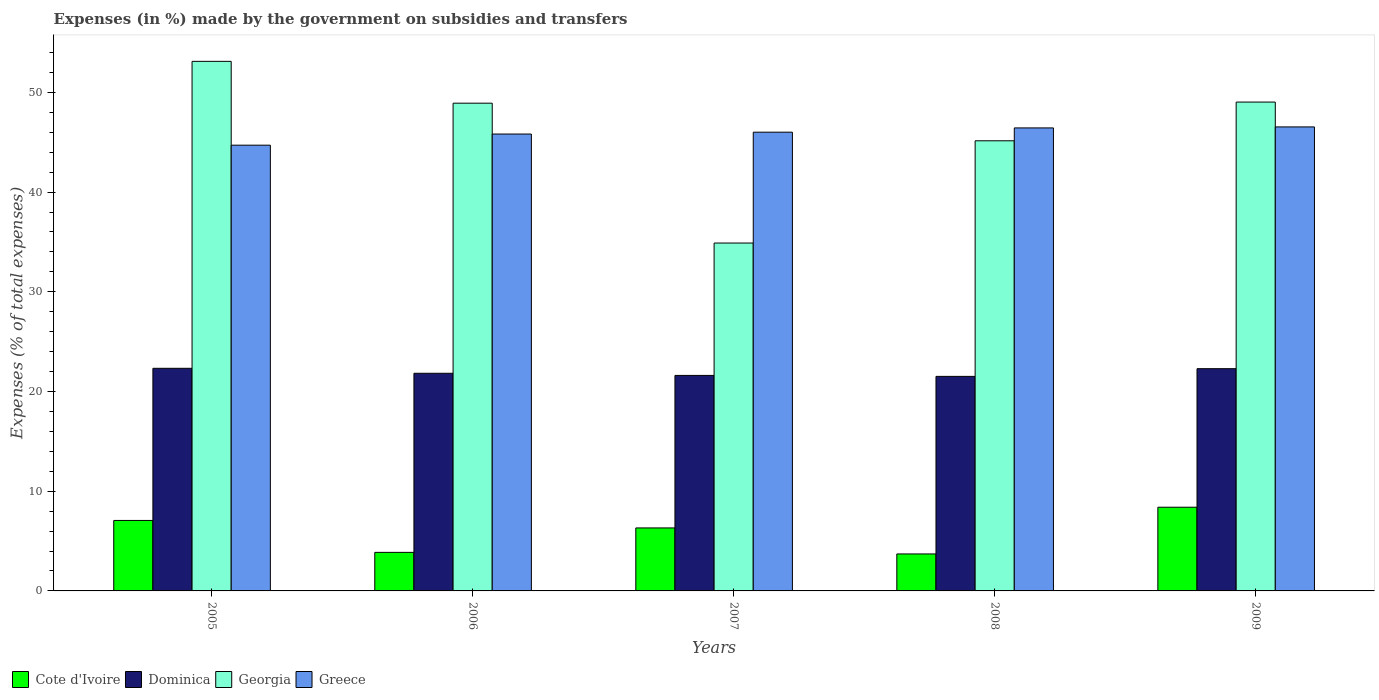How many different coloured bars are there?
Your answer should be very brief. 4. Are the number of bars on each tick of the X-axis equal?
Give a very brief answer. Yes. How many bars are there on the 4th tick from the left?
Your answer should be compact. 4. What is the label of the 1st group of bars from the left?
Offer a very short reply. 2005. In how many cases, is the number of bars for a given year not equal to the number of legend labels?
Your response must be concise. 0. What is the percentage of expenses made by the government on subsidies and transfers in Greece in 2009?
Your response must be concise. 46.53. Across all years, what is the maximum percentage of expenses made by the government on subsidies and transfers in Cote d'Ivoire?
Your answer should be very brief. 8.39. Across all years, what is the minimum percentage of expenses made by the government on subsidies and transfers in Cote d'Ivoire?
Give a very brief answer. 3.71. What is the total percentage of expenses made by the government on subsidies and transfers in Greece in the graph?
Keep it short and to the point. 229.49. What is the difference between the percentage of expenses made by the government on subsidies and transfers in Cote d'Ivoire in 2008 and that in 2009?
Your answer should be very brief. -4.69. What is the difference between the percentage of expenses made by the government on subsidies and transfers in Cote d'Ivoire in 2009 and the percentage of expenses made by the government on subsidies and transfers in Dominica in 2006?
Your response must be concise. -13.43. What is the average percentage of expenses made by the government on subsidies and transfers in Greece per year?
Make the answer very short. 45.9. In the year 2009, what is the difference between the percentage of expenses made by the government on subsidies and transfers in Georgia and percentage of expenses made by the government on subsidies and transfers in Dominica?
Offer a terse response. 26.74. In how many years, is the percentage of expenses made by the government on subsidies and transfers in Greece greater than 42 %?
Your answer should be very brief. 5. What is the ratio of the percentage of expenses made by the government on subsidies and transfers in Dominica in 2005 to that in 2006?
Provide a short and direct response. 1.02. Is the difference between the percentage of expenses made by the government on subsidies and transfers in Georgia in 2005 and 2007 greater than the difference between the percentage of expenses made by the government on subsidies and transfers in Dominica in 2005 and 2007?
Your answer should be very brief. Yes. What is the difference between the highest and the second highest percentage of expenses made by the government on subsidies and transfers in Dominica?
Provide a succinct answer. 0.04. What is the difference between the highest and the lowest percentage of expenses made by the government on subsidies and transfers in Dominica?
Your response must be concise. 0.81. In how many years, is the percentage of expenses made by the government on subsidies and transfers in Dominica greater than the average percentage of expenses made by the government on subsidies and transfers in Dominica taken over all years?
Ensure brevity in your answer.  2. What does the 1st bar from the left in 2006 represents?
Provide a succinct answer. Cote d'Ivoire. What does the 2nd bar from the right in 2006 represents?
Provide a succinct answer. Georgia. Is it the case that in every year, the sum of the percentage of expenses made by the government on subsidies and transfers in Cote d'Ivoire and percentage of expenses made by the government on subsidies and transfers in Georgia is greater than the percentage of expenses made by the government on subsidies and transfers in Greece?
Your answer should be compact. No. What is the difference between two consecutive major ticks on the Y-axis?
Your answer should be compact. 10. Are the values on the major ticks of Y-axis written in scientific E-notation?
Ensure brevity in your answer.  No. Does the graph contain any zero values?
Your answer should be compact. No. Does the graph contain grids?
Your answer should be compact. No. How many legend labels are there?
Keep it short and to the point. 4. What is the title of the graph?
Provide a succinct answer. Expenses (in %) made by the government on subsidies and transfers. Does "North America" appear as one of the legend labels in the graph?
Your answer should be compact. No. What is the label or title of the X-axis?
Keep it short and to the point. Years. What is the label or title of the Y-axis?
Make the answer very short. Expenses (% of total expenses). What is the Expenses (% of total expenses) in Cote d'Ivoire in 2005?
Give a very brief answer. 7.07. What is the Expenses (% of total expenses) of Dominica in 2005?
Keep it short and to the point. 22.33. What is the Expenses (% of total expenses) in Georgia in 2005?
Offer a terse response. 53.11. What is the Expenses (% of total expenses) in Greece in 2005?
Keep it short and to the point. 44.7. What is the Expenses (% of total expenses) of Cote d'Ivoire in 2006?
Make the answer very short. 3.87. What is the Expenses (% of total expenses) in Dominica in 2006?
Offer a very short reply. 21.83. What is the Expenses (% of total expenses) in Georgia in 2006?
Ensure brevity in your answer.  48.91. What is the Expenses (% of total expenses) of Greece in 2006?
Give a very brief answer. 45.82. What is the Expenses (% of total expenses) in Cote d'Ivoire in 2007?
Provide a short and direct response. 6.32. What is the Expenses (% of total expenses) in Dominica in 2007?
Offer a very short reply. 21.61. What is the Expenses (% of total expenses) in Georgia in 2007?
Your answer should be very brief. 34.89. What is the Expenses (% of total expenses) in Greece in 2007?
Keep it short and to the point. 46. What is the Expenses (% of total expenses) in Cote d'Ivoire in 2008?
Provide a succinct answer. 3.71. What is the Expenses (% of total expenses) in Dominica in 2008?
Provide a short and direct response. 21.52. What is the Expenses (% of total expenses) in Georgia in 2008?
Give a very brief answer. 45.14. What is the Expenses (% of total expenses) in Greece in 2008?
Your answer should be very brief. 46.43. What is the Expenses (% of total expenses) in Cote d'Ivoire in 2009?
Offer a very short reply. 8.39. What is the Expenses (% of total expenses) in Dominica in 2009?
Make the answer very short. 22.29. What is the Expenses (% of total expenses) in Georgia in 2009?
Give a very brief answer. 49.03. What is the Expenses (% of total expenses) in Greece in 2009?
Provide a short and direct response. 46.53. Across all years, what is the maximum Expenses (% of total expenses) of Cote d'Ivoire?
Give a very brief answer. 8.39. Across all years, what is the maximum Expenses (% of total expenses) of Dominica?
Your response must be concise. 22.33. Across all years, what is the maximum Expenses (% of total expenses) of Georgia?
Your response must be concise. 53.11. Across all years, what is the maximum Expenses (% of total expenses) of Greece?
Your answer should be compact. 46.53. Across all years, what is the minimum Expenses (% of total expenses) in Cote d'Ivoire?
Give a very brief answer. 3.71. Across all years, what is the minimum Expenses (% of total expenses) in Dominica?
Your answer should be compact. 21.52. Across all years, what is the minimum Expenses (% of total expenses) of Georgia?
Offer a very short reply. 34.89. Across all years, what is the minimum Expenses (% of total expenses) of Greece?
Offer a terse response. 44.7. What is the total Expenses (% of total expenses) of Cote d'Ivoire in the graph?
Give a very brief answer. 29.35. What is the total Expenses (% of total expenses) of Dominica in the graph?
Offer a very short reply. 109.57. What is the total Expenses (% of total expenses) in Georgia in the graph?
Give a very brief answer. 231.07. What is the total Expenses (% of total expenses) of Greece in the graph?
Your answer should be very brief. 229.49. What is the difference between the Expenses (% of total expenses) in Cote d'Ivoire in 2005 and that in 2006?
Keep it short and to the point. 3.2. What is the difference between the Expenses (% of total expenses) of Dominica in 2005 and that in 2006?
Your answer should be compact. 0.5. What is the difference between the Expenses (% of total expenses) in Georgia in 2005 and that in 2006?
Your answer should be very brief. 4.2. What is the difference between the Expenses (% of total expenses) in Greece in 2005 and that in 2006?
Provide a short and direct response. -1.12. What is the difference between the Expenses (% of total expenses) in Cote d'Ivoire in 2005 and that in 2007?
Your answer should be very brief. 0.75. What is the difference between the Expenses (% of total expenses) in Dominica in 2005 and that in 2007?
Your answer should be very brief. 0.71. What is the difference between the Expenses (% of total expenses) of Georgia in 2005 and that in 2007?
Provide a succinct answer. 18.22. What is the difference between the Expenses (% of total expenses) of Greece in 2005 and that in 2007?
Provide a succinct answer. -1.3. What is the difference between the Expenses (% of total expenses) in Cote d'Ivoire in 2005 and that in 2008?
Give a very brief answer. 3.36. What is the difference between the Expenses (% of total expenses) of Dominica in 2005 and that in 2008?
Your answer should be compact. 0.81. What is the difference between the Expenses (% of total expenses) in Georgia in 2005 and that in 2008?
Your answer should be very brief. 7.97. What is the difference between the Expenses (% of total expenses) of Greece in 2005 and that in 2008?
Offer a very short reply. -1.73. What is the difference between the Expenses (% of total expenses) of Cote d'Ivoire in 2005 and that in 2009?
Offer a terse response. -1.33. What is the difference between the Expenses (% of total expenses) of Dominica in 2005 and that in 2009?
Provide a succinct answer. 0.04. What is the difference between the Expenses (% of total expenses) of Georgia in 2005 and that in 2009?
Provide a succinct answer. 4.08. What is the difference between the Expenses (% of total expenses) in Greece in 2005 and that in 2009?
Offer a very short reply. -1.83. What is the difference between the Expenses (% of total expenses) in Cote d'Ivoire in 2006 and that in 2007?
Offer a very short reply. -2.45. What is the difference between the Expenses (% of total expenses) in Dominica in 2006 and that in 2007?
Offer a very short reply. 0.21. What is the difference between the Expenses (% of total expenses) in Georgia in 2006 and that in 2007?
Ensure brevity in your answer.  14.03. What is the difference between the Expenses (% of total expenses) of Greece in 2006 and that in 2007?
Offer a terse response. -0.19. What is the difference between the Expenses (% of total expenses) of Cote d'Ivoire in 2006 and that in 2008?
Provide a succinct answer. 0.16. What is the difference between the Expenses (% of total expenses) in Dominica in 2006 and that in 2008?
Give a very brief answer. 0.31. What is the difference between the Expenses (% of total expenses) in Georgia in 2006 and that in 2008?
Offer a very short reply. 3.77. What is the difference between the Expenses (% of total expenses) in Greece in 2006 and that in 2008?
Your answer should be compact. -0.61. What is the difference between the Expenses (% of total expenses) in Cote d'Ivoire in 2006 and that in 2009?
Offer a very short reply. -4.53. What is the difference between the Expenses (% of total expenses) in Dominica in 2006 and that in 2009?
Keep it short and to the point. -0.46. What is the difference between the Expenses (% of total expenses) in Georgia in 2006 and that in 2009?
Keep it short and to the point. -0.11. What is the difference between the Expenses (% of total expenses) of Greece in 2006 and that in 2009?
Offer a terse response. -0.71. What is the difference between the Expenses (% of total expenses) in Cote d'Ivoire in 2007 and that in 2008?
Offer a very short reply. 2.61. What is the difference between the Expenses (% of total expenses) of Dominica in 2007 and that in 2008?
Provide a short and direct response. 0.1. What is the difference between the Expenses (% of total expenses) in Georgia in 2007 and that in 2008?
Your response must be concise. -10.26. What is the difference between the Expenses (% of total expenses) of Greece in 2007 and that in 2008?
Keep it short and to the point. -0.43. What is the difference between the Expenses (% of total expenses) in Cote d'Ivoire in 2007 and that in 2009?
Provide a short and direct response. -2.08. What is the difference between the Expenses (% of total expenses) of Dominica in 2007 and that in 2009?
Give a very brief answer. -0.68. What is the difference between the Expenses (% of total expenses) of Georgia in 2007 and that in 2009?
Your response must be concise. -14.14. What is the difference between the Expenses (% of total expenses) of Greece in 2007 and that in 2009?
Your answer should be very brief. -0.53. What is the difference between the Expenses (% of total expenses) in Cote d'Ivoire in 2008 and that in 2009?
Your answer should be very brief. -4.69. What is the difference between the Expenses (% of total expenses) in Dominica in 2008 and that in 2009?
Keep it short and to the point. -0.77. What is the difference between the Expenses (% of total expenses) of Georgia in 2008 and that in 2009?
Your answer should be very brief. -3.88. What is the difference between the Expenses (% of total expenses) in Greece in 2008 and that in 2009?
Make the answer very short. -0.1. What is the difference between the Expenses (% of total expenses) of Cote d'Ivoire in 2005 and the Expenses (% of total expenses) of Dominica in 2006?
Provide a short and direct response. -14.76. What is the difference between the Expenses (% of total expenses) of Cote d'Ivoire in 2005 and the Expenses (% of total expenses) of Georgia in 2006?
Give a very brief answer. -41.85. What is the difference between the Expenses (% of total expenses) in Cote d'Ivoire in 2005 and the Expenses (% of total expenses) in Greece in 2006?
Offer a terse response. -38.75. What is the difference between the Expenses (% of total expenses) of Dominica in 2005 and the Expenses (% of total expenses) of Georgia in 2006?
Offer a very short reply. -26.59. What is the difference between the Expenses (% of total expenses) of Dominica in 2005 and the Expenses (% of total expenses) of Greece in 2006?
Offer a terse response. -23.49. What is the difference between the Expenses (% of total expenses) of Georgia in 2005 and the Expenses (% of total expenses) of Greece in 2006?
Your answer should be very brief. 7.29. What is the difference between the Expenses (% of total expenses) in Cote d'Ivoire in 2005 and the Expenses (% of total expenses) in Dominica in 2007?
Provide a succinct answer. -14.55. What is the difference between the Expenses (% of total expenses) of Cote d'Ivoire in 2005 and the Expenses (% of total expenses) of Georgia in 2007?
Provide a succinct answer. -27.82. What is the difference between the Expenses (% of total expenses) of Cote d'Ivoire in 2005 and the Expenses (% of total expenses) of Greece in 2007?
Make the answer very short. -38.94. What is the difference between the Expenses (% of total expenses) in Dominica in 2005 and the Expenses (% of total expenses) in Georgia in 2007?
Keep it short and to the point. -12.56. What is the difference between the Expenses (% of total expenses) in Dominica in 2005 and the Expenses (% of total expenses) in Greece in 2007?
Keep it short and to the point. -23.68. What is the difference between the Expenses (% of total expenses) in Georgia in 2005 and the Expenses (% of total expenses) in Greece in 2007?
Offer a terse response. 7.1. What is the difference between the Expenses (% of total expenses) in Cote d'Ivoire in 2005 and the Expenses (% of total expenses) in Dominica in 2008?
Make the answer very short. -14.45. What is the difference between the Expenses (% of total expenses) in Cote d'Ivoire in 2005 and the Expenses (% of total expenses) in Georgia in 2008?
Offer a very short reply. -38.07. What is the difference between the Expenses (% of total expenses) of Cote d'Ivoire in 2005 and the Expenses (% of total expenses) of Greece in 2008?
Offer a very short reply. -39.36. What is the difference between the Expenses (% of total expenses) in Dominica in 2005 and the Expenses (% of total expenses) in Georgia in 2008?
Keep it short and to the point. -22.82. What is the difference between the Expenses (% of total expenses) of Dominica in 2005 and the Expenses (% of total expenses) of Greece in 2008?
Your answer should be very brief. -24.11. What is the difference between the Expenses (% of total expenses) of Georgia in 2005 and the Expenses (% of total expenses) of Greece in 2008?
Offer a terse response. 6.68. What is the difference between the Expenses (% of total expenses) of Cote d'Ivoire in 2005 and the Expenses (% of total expenses) of Dominica in 2009?
Provide a succinct answer. -15.22. What is the difference between the Expenses (% of total expenses) in Cote d'Ivoire in 2005 and the Expenses (% of total expenses) in Georgia in 2009?
Offer a terse response. -41.96. What is the difference between the Expenses (% of total expenses) in Cote d'Ivoire in 2005 and the Expenses (% of total expenses) in Greece in 2009?
Provide a succinct answer. -39.47. What is the difference between the Expenses (% of total expenses) of Dominica in 2005 and the Expenses (% of total expenses) of Georgia in 2009?
Ensure brevity in your answer.  -26.7. What is the difference between the Expenses (% of total expenses) in Dominica in 2005 and the Expenses (% of total expenses) in Greece in 2009?
Keep it short and to the point. -24.21. What is the difference between the Expenses (% of total expenses) in Georgia in 2005 and the Expenses (% of total expenses) in Greece in 2009?
Make the answer very short. 6.57. What is the difference between the Expenses (% of total expenses) of Cote d'Ivoire in 2006 and the Expenses (% of total expenses) of Dominica in 2007?
Provide a short and direct response. -17.75. What is the difference between the Expenses (% of total expenses) in Cote d'Ivoire in 2006 and the Expenses (% of total expenses) in Georgia in 2007?
Provide a succinct answer. -31.02. What is the difference between the Expenses (% of total expenses) of Cote d'Ivoire in 2006 and the Expenses (% of total expenses) of Greece in 2007?
Make the answer very short. -42.14. What is the difference between the Expenses (% of total expenses) of Dominica in 2006 and the Expenses (% of total expenses) of Georgia in 2007?
Offer a terse response. -13.06. What is the difference between the Expenses (% of total expenses) of Dominica in 2006 and the Expenses (% of total expenses) of Greece in 2007?
Offer a terse response. -24.18. What is the difference between the Expenses (% of total expenses) of Georgia in 2006 and the Expenses (% of total expenses) of Greece in 2007?
Your answer should be compact. 2.91. What is the difference between the Expenses (% of total expenses) of Cote d'Ivoire in 2006 and the Expenses (% of total expenses) of Dominica in 2008?
Keep it short and to the point. -17.65. What is the difference between the Expenses (% of total expenses) in Cote d'Ivoire in 2006 and the Expenses (% of total expenses) in Georgia in 2008?
Your answer should be compact. -41.28. What is the difference between the Expenses (% of total expenses) in Cote d'Ivoire in 2006 and the Expenses (% of total expenses) in Greece in 2008?
Provide a short and direct response. -42.57. What is the difference between the Expenses (% of total expenses) in Dominica in 2006 and the Expenses (% of total expenses) in Georgia in 2008?
Give a very brief answer. -23.32. What is the difference between the Expenses (% of total expenses) of Dominica in 2006 and the Expenses (% of total expenses) of Greece in 2008?
Your answer should be very brief. -24.61. What is the difference between the Expenses (% of total expenses) of Georgia in 2006 and the Expenses (% of total expenses) of Greece in 2008?
Your response must be concise. 2.48. What is the difference between the Expenses (% of total expenses) in Cote d'Ivoire in 2006 and the Expenses (% of total expenses) in Dominica in 2009?
Keep it short and to the point. -18.42. What is the difference between the Expenses (% of total expenses) of Cote d'Ivoire in 2006 and the Expenses (% of total expenses) of Georgia in 2009?
Offer a very short reply. -45.16. What is the difference between the Expenses (% of total expenses) in Cote d'Ivoire in 2006 and the Expenses (% of total expenses) in Greece in 2009?
Offer a terse response. -42.67. What is the difference between the Expenses (% of total expenses) in Dominica in 2006 and the Expenses (% of total expenses) in Georgia in 2009?
Provide a succinct answer. -27.2. What is the difference between the Expenses (% of total expenses) in Dominica in 2006 and the Expenses (% of total expenses) in Greece in 2009?
Keep it short and to the point. -24.71. What is the difference between the Expenses (% of total expenses) of Georgia in 2006 and the Expenses (% of total expenses) of Greece in 2009?
Give a very brief answer. 2.38. What is the difference between the Expenses (% of total expenses) in Cote d'Ivoire in 2007 and the Expenses (% of total expenses) in Dominica in 2008?
Make the answer very short. -15.2. What is the difference between the Expenses (% of total expenses) of Cote d'Ivoire in 2007 and the Expenses (% of total expenses) of Georgia in 2008?
Your answer should be compact. -38.83. What is the difference between the Expenses (% of total expenses) in Cote d'Ivoire in 2007 and the Expenses (% of total expenses) in Greece in 2008?
Make the answer very short. -40.12. What is the difference between the Expenses (% of total expenses) in Dominica in 2007 and the Expenses (% of total expenses) in Georgia in 2008?
Provide a short and direct response. -23.53. What is the difference between the Expenses (% of total expenses) of Dominica in 2007 and the Expenses (% of total expenses) of Greece in 2008?
Your answer should be compact. -24.82. What is the difference between the Expenses (% of total expenses) in Georgia in 2007 and the Expenses (% of total expenses) in Greece in 2008?
Your response must be concise. -11.55. What is the difference between the Expenses (% of total expenses) in Cote d'Ivoire in 2007 and the Expenses (% of total expenses) in Dominica in 2009?
Make the answer very short. -15.97. What is the difference between the Expenses (% of total expenses) in Cote d'Ivoire in 2007 and the Expenses (% of total expenses) in Georgia in 2009?
Give a very brief answer. -42.71. What is the difference between the Expenses (% of total expenses) in Cote d'Ivoire in 2007 and the Expenses (% of total expenses) in Greece in 2009?
Give a very brief answer. -40.22. What is the difference between the Expenses (% of total expenses) of Dominica in 2007 and the Expenses (% of total expenses) of Georgia in 2009?
Offer a very short reply. -27.41. What is the difference between the Expenses (% of total expenses) of Dominica in 2007 and the Expenses (% of total expenses) of Greece in 2009?
Ensure brevity in your answer.  -24.92. What is the difference between the Expenses (% of total expenses) of Georgia in 2007 and the Expenses (% of total expenses) of Greece in 2009?
Offer a very short reply. -11.65. What is the difference between the Expenses (% of total expenses) of Cote d'Ivoire in 2008 and the Expenses (% of total expenses) of Dominica in 2009?
Your answer should be compact. -18.58. What is the difference between the Expenses (% of total expenses) of Cote d'Ivoire in 2008 and the Expenses (% of total expenses) of Georgia in 2009?
Ensure brevity in your answer.  -45.32. What is the difference between the Expenses (% of total expenses) in Cote d'Ivoire in 2008 and the Expenses (% of total expenses) in Greece in 2009?
Offer a very short reply. -42.83. What is the difference between the Expenses (% of total expenses) in Dominica in 2008 and the Expenses (% of total expenses) in Georgia in 2009?
Provide a succinct answer. -27.51. What is the difference between the Expenses (% of total expenses) in Dominica in 2008 and the Expenses (% of total expenses) in Greece in 2009?
Your answer should be very brief. -25.02. What is the difference between the Expenses (% of total expenses) of Georgia in 2008 and the Expenses (% of total expenses) of Greece in 2009?
Make the answer very short. -1.39. What is the average Expenses (% of total expenses) of Cote d'Ivoire per year?
Keep it short and to the point. 5.87. What is the average Expenses (% of total expenses) in Dominica per year?
Your answer should be very brief. 21.91. What is the average Expenses (% of total expenses) in Georgia per year?
Keep it short and to the point. 46.21. What is the average Expenses (% of total expenses) in Greece per year?
Keep it short and to the point. 45.9. In the year 2005, what is the difference between the Expenses (% of total expenses) in Cote d'Ivoire and Expenses (% of total expenses) in Dominica?
Provide a succinct answer. -15.26. In the year 2005, what is the difference between the Expenses (% of total expenses) in Cote d'Ivoire and Expenses (% of total expenses) in Georgia?
Provide a succinct answer. -46.04. In the year 2005, what is the difference between the Expenses (% of total expenses) in Cote d'Ivoire and Expenses (% of total expenses) in Greece?
Offer a terse response. -37.63. In the year 2005, what is the difference between the Expenses (% of total expenses) of Dominica and Expenses (% of total expenses) of Georgia?
Ensure brevity in your answer.  -30.78. In the year 2005, what is the difference between the Expenses (% of total expenses) of Dominica and Expenses (% of total expenses) of Greece?
Give a very brief answer. -22.38. In the year 2005, what is the difference between the Expenses (% of total expenses) of Georgia and Expenses (% of total expenses) of Greece?
Offer a very short reply. 8.41. In the year 2006, what is the difference between the Expenses (% of total expenses) of Cote d'Ivoire and Expenses (% of total expenses) of Dominica?
Provide a succinct answer. -17.96. In the year 2006, what is the difference between the Expenses (% of total expenses) in Cote d'Ivoire and Expenses (% of total expenses) in Georgia?
Provide a short and direct response. -45.05. In the year 2006, what is the difference between the Expenses (% of total expenses) of Cote d'Ivoire and Expenses (% of total expenses) of Greece?
Make the answer very short. -41.95. In the year 2006, what is the difference between the Expenses (% of total expenses) of Dominica and Expenses (% of total expenses) of Georgia?
Keep it short and to the point. -27.09. In the year 2006, what is the difference between the Expenses (% of total expenses) in Dominica and Expenses (% of total expenses) in Greece?
Offer a terse response. -23.99. In the year 2006, what is the difference between the Expenses (% of total expenses) of Georgia and Expenses (% of total expenses) of Greece?
Give a very brief answer. 3.09. In the year 2007, what is the difference between the Expenses (% of total expenses) in Cote d'Ivoire and Expenses (% of total expenses) in Dominica?
Your answer should be compact. -15.3. In the year 2007, what is the difference between the Expenses (% of total expenses) of Cote d'Ivoire and Expenses (% of total expenses) of Georgia?
Provide a succinct answer. -28.57. In the year 2007, what is the difference between the Expenses (% of total expenses) in Cote d'Ivoire and Expenses (% of total expenses) in Greece?
Offer a very short reply. -39.69. In the year 2007, what is the difference between the Expenses (% of total expenses) of Dominica and Expenses (% of total expenses) of Georgia?
Your response must be concise. -13.27. In the year 2007, what is the difference between the Expenses (% of total expenses) of Dominica and Expenses (% of total expenses) of Greece?
Provide a short and direct response. -24.39. In the year 2007, what is the difference between the Expenses (% of total expenses) in Georgia and Expenses (% of total expenses) in Greece?
Your answer should be compact. -11.12. In the year 2008, what is the difference between the Expenses (% of total expenses) of Cote d'Ivoire and Expenses (% of total expenses) of Dominica?
Your answer should be compact. -17.81. In the year 2008, what is the difference between the Expenses (% of total expenses) of Cote d'Ivoire and Expenses (% of total expenses) of Georgia?
Give a very brief answer. -41.43. In the year 2008, what is the difference between the Expenses (% of total expenses) of Cote d'Ivoire and Expenses (% of total expenses) of Greece?
Your response must be concise. -42.72. In the year 2008, what is the difference between the Expenses (% of total expenses) in Dominica and Expenses (% of total expenses) in Georgia?
Give a very brief answer. -23.63. In the year 2008, what is the difference between the Expenses (% of total expenses) of Dominica and Expenses (% of total expenses) of Greece?
Provide a succinct answer. -24.92. In the year 2008, what is the difference between the Expenses (% of total expenses) of Georgia and Expenses (% of total expenses) of Greece?
Your response must be concise. -1.29. In the year 2009, what is the difference between the Expenses (% of total expenses) of Cote d'Ivoire and Expenses (% of total expenses) of Dominica?
Your answer should be compact. -13.89. In the year 2009, what is the difference between the Expenses (% of total expenses) of Cote d'Ivoire and Expenses (% of total expenses) of Georgia?
Your response must be concise. -40.63. In the year 2009, what is the difference between the Expenses (% of total expenses) of Cote d'Ivoire and Expenses (% of total expenses) of Greece?
Your response must be concise. -38.14. In the year 2009, what is the difference between the Expenses (% of total expenses) in Dominica and Expenses (% of total expenses) in Georgia?
Offer a terse response. -26.74. In the year 2009, what is the difference between the Expenses (% of total expenses) of Dominica and Expenses (% of total expenses) of Greece?
Your answer should be very brief. -24.25. In the year 2009, what is the difference between the Expenses (% of total expenses) in Georgia and Expenses (% of total expenses) in Greece?
Provide a short and direct response. 2.49. What is the ratio of the Expenses (% of total expenses) in Cote d'Ivoire in 2005 to that in 2006?
Ensure brevity in your answer.  1.83. What is the ratio of the Expenses (% of total expenses) in Dominica in 2005 to that in 2006?
Keep it short and to the point. 1.02. What is the ratio of the Expenses (% of total expenses) in Georgia in 2005 to that in 2006?
Your response must be concise. 1.09. What is the ratio of the Expenses (% of total expenses) in Greece in 2005 to that in 2006?
Offer a terse response. 0.98. What is the ratio of the Expenses (% of total expenses) in Cote d'Ivoire in 2005 to that in 2007?
Offer a terse response. 1.12. What is the ratio of the Expenses (% of total expenses) of Dominica in 2005 to that in 2007?
Offer a terse response. 1.03. What is the ratio of the Expenses (% of total expenses) in Georgia in 2005 to that in 2007?
Provide a short and direct response. 1.52. What is the ratio of the Expenses (% of total expenses) in Greece in 2005 to that in 2007?
Offer a very short reply. 0.97. What is the ratio of the Expenses (% of total expenses) of Cote d'Ivoire in 2005 to that in 2008?
Your response must be concise. 1.91. What is the ratio of the Expenses (% of total expenses) of Dominica in 2005 to that in 2008?
Make the answer very short. 1.04. What is the ratio of the Expenses (% of total expenses) in Georgia in 2005 to that in 2008?
Keep it short and to the point. 1.18. What is the ratio of the Expenses (% of total expenses) in Greece in 2005 to that in 2008?
Your answer should be compact. 0.96. What is the ratio of the Expenses (% of total expenses) of Cote d'Ivoire in 2005 to that in 2009?
Your response must be concise. 0.84. What is the ratio of the Expenses (% of total expenses) in Dominica in 2005 to that in 2009?
Provide a short and direct response. 1. What is the ratio of the Expenses (% of total expenses) in Georgia in 2005 to that in 2009?
Keep it short and to the point. 1.08. What is the ratio of the Expenses (% of total expenses) of Greece in 2005 to that in 2009?
Offer a terse response. 0.96. What is the ratio of the Expenses (% of total expenses) of Cote d'Ivoire in 2006 to that in 2007?
Offer a very short reply. 0.61. What is the ratio of the Expenses (% of total expenses) in Dominica in 2006 to that in 2007?
Give a very brief answer. 1.01. What is the ratio of the Expenses (% of total expenses) in Georgia in 2006 to that in 2007?
Your response must be concise. 1.4. What is the ratio of the Expenses (% of total expenses) of Greece in 2006 to that in 2007?
Give a very brief answer. 1. What is the ratio of the Expenses (% of total expenses) of Cote d'Ivoire in 2006 to that in 2008?
Provide a succinct answer. 1.04. What is the ratio of the Expenses (% of total expenses) in Dominica in 2006 to that in 2008?
Give a very brief answer. 1.01. What is the ratio of the Expenses (% of total expenses) of Georgia in 2006 to that in 2008?
Provide a short and direct response. 1.08. What is the ratio of the Expenses (% of total expenses) in Greece in 2006 to that in 2008?
Offer a terse response. 0.99. What is the ratio of the Expenses (% of total expenses) of Cote d'Ivoire in 2006 to that in 2009?
Your response must be concise. 0.46. What is the ratio of the Expenses (% of total expenses) in Dominica in 2006 to that in 2009?
Give a very brief answer. 0.98. What is the ratio of the Expenses (% of total expenses) of Georgia in 2006 to that in 2009?
Your answer should be very brief. 1. What is the ratio of the Expenses (% of total expenses) in Greece in 2006 to that in 2009?
Provide a succinct answer. 0.98. What is the ratio of the Expenses (% of total expenses) in Cote d'Ivoire in 2007 to that in 2008?
Provide a succinct answer. 1.7. What is the ratio of the Expenses (% of total expenses) in Georgia in 2007 to that in 2008?
Your answer should be compact. 0.77. What is the ratio of the Expenses (% of total expenses) of Greece in 2007 to that in 2008?
Offer a terse response. 0.99. What is the ratio of the Expenses (% of total expenses) in Cote d'Ivoire in 2007 to that in 2009?
Your response must be concise. 0.75. What is the ratio of the Expenses (% of total expenses) in Dominica in 2007 to that in 2009?
Your answer should be very brief. 0.97. What is the ratio of the Expenses (% of total expenses) of Georgia in 2007 to that in 2009?
Provide a succinct answer. 0.71. What is the ratio of the Expenses (% of total expenses) in Cote d'Ivoire in 2008 to that in 2009?
Ensure brevity in your answer.  0.44. What is the ratio of the Expenses (% of total expenses) in Dominica in 2008 to that in 2009?
Your answer should be compact. 0.97. What is the ratio of the Expenses (% of total expenses) in Georgia in 2008 to that in 2009?
Offer a terse response. 0.92. What is the ratio of the Expenses (% of total expenses) of Greece in 2008 to that in 2009?
Provide a short and direct response. 1. What is the difference between the highest and the second highest Expenses (% of total expenses) in Cote d'Ivoire?
Keep it short and to the point. 1.33. What is the difference between the highest and the second highest Expenses (% of total expenses) in Dominica?
Your answer should be compact. 0.04. What is the difference between the highest and the second highest Expenses (% of total expenses) in Georgia?
Offer a very short reply. 4.08. What is the difference between the highest and the second highest Expenses (% of total expenses) of Greece?
Your response must be concise. 0.1. What is the difference between the highest and the lowest Expenses (% of total expenses) in Cote d'Ivoire?
Provide a succinct answer. 4.69. What is the difference between the highest and the lowest Expenses (% of total expenses) of Dominica?
Your answer should be very brief. 0.81. What is the difference between the highest and the lowest Expenses (% of total expenses) of Georgia?
Offer a terse response. 18.22. What is the difference between the highest and the lowest Expenses (% of total expenses) in Greece?
Keep it short and to the point. 1.83. 